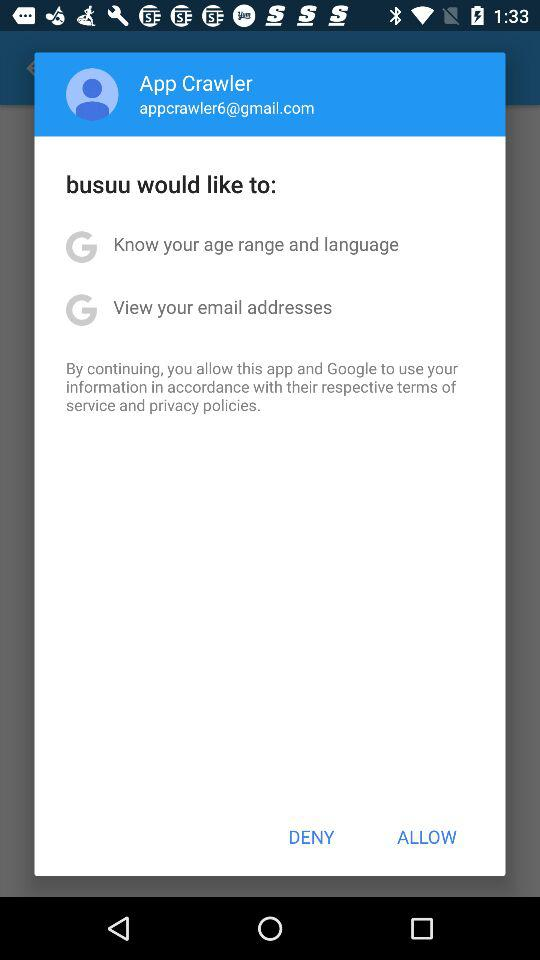What is the user name? The user name is App Crawler. 